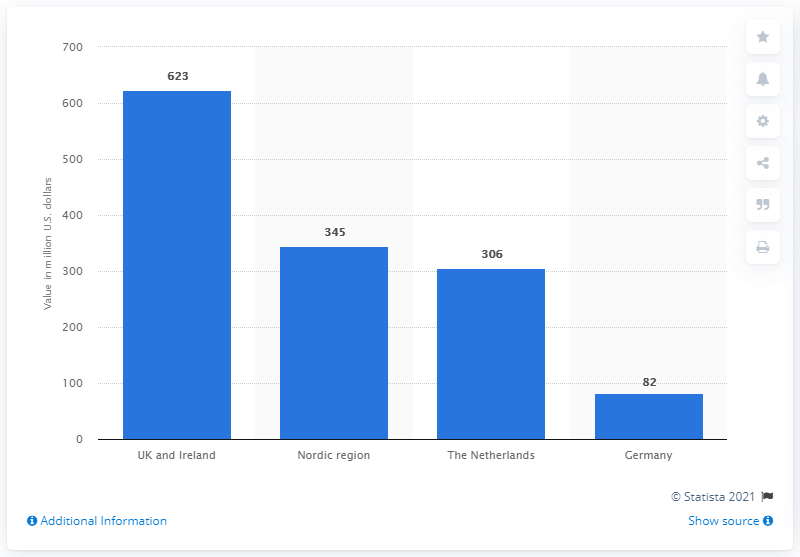Point out several critical features in this image. In 2014, a total of 345 million dollars was invested in new companies in the Nordic region. In 2014, UK and Irish Fintech companies developed innovative financial services that attracted a total of 623 dollars. 